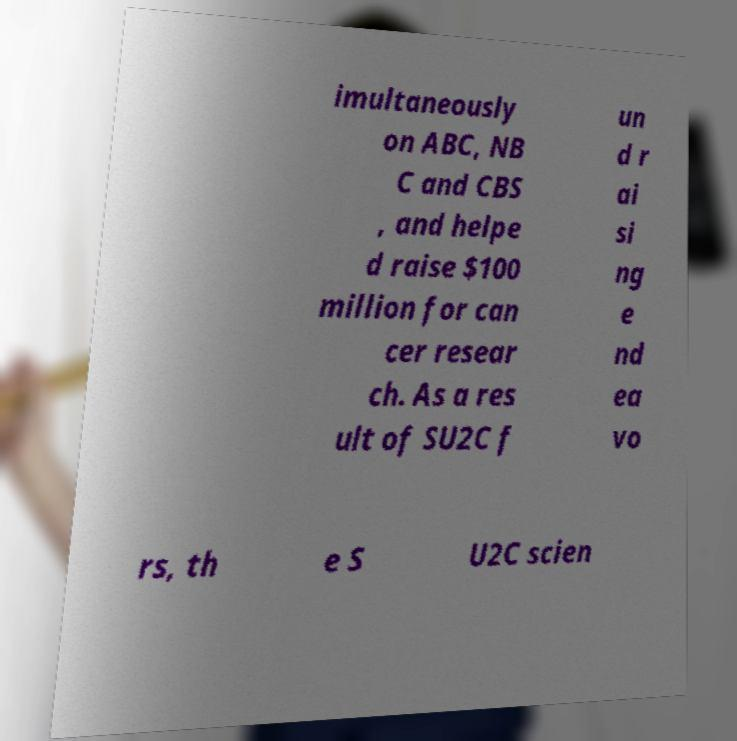What messages or text are displayed in this image? I need them in a readable, typed format. imultaneously on ABC, NB C and CBS , and helpe d raise $100 million for can cer resear ch. As a res ult of SU2C f un d r ai si ng e nd ea vo rs, th e S U2C scien 